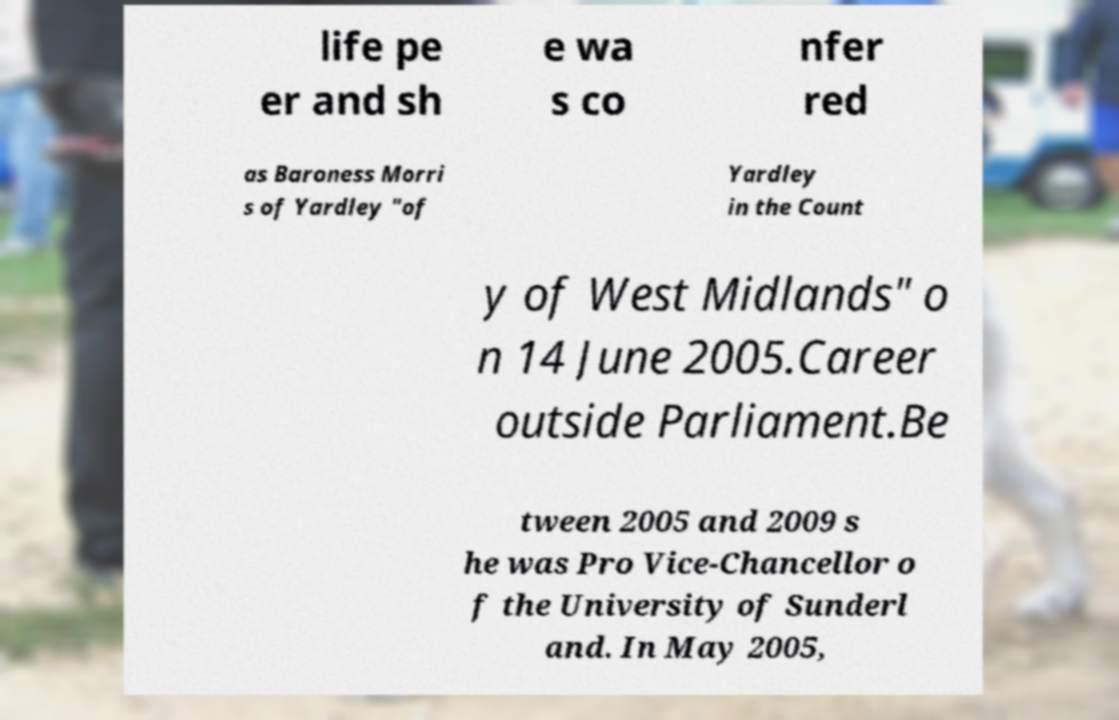For documentation purposes, I need the text within this image transcribed. Could you provide that? life pe er and sh e wa s co nfer red as Baroness Morri s of Yardley "of Yardley in the Count y of West Midlands" o n 14 June 2005.Career outside Parliament.Be tween 2005 and 2009 s he was Pro Vice-Chancellor o f the University of Sunderl and. In May 2005, 